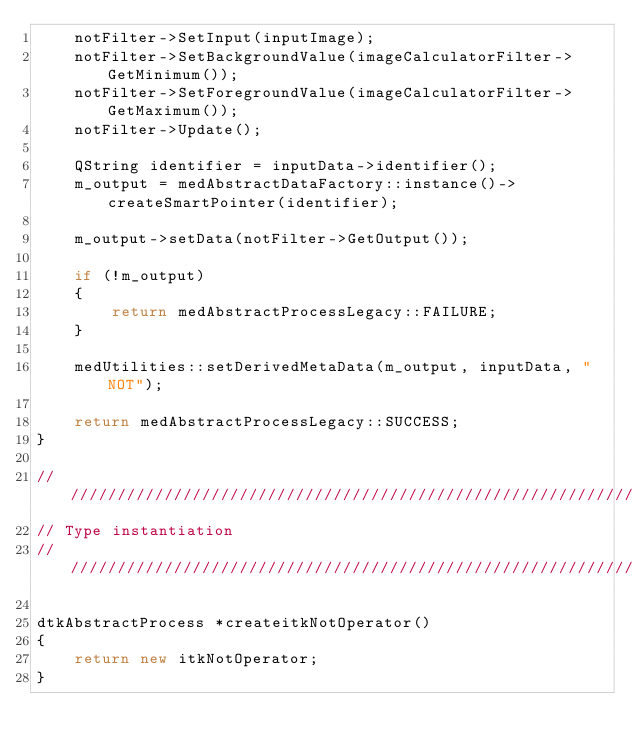Convert code to text. <code><loc_0><loc_0><loc_500><loc_500><_C++_>    notFilter->SetInput(inputImage);
    notFilter->SetBackgroundValue(imageCalculatorFilter->GetMinimum());
    notFilter->SetForegroundValue(imageCalculatorFilter->GetMaximum());
    notFilter->Update();

    QString identifier = inputData->identifier();
    m_output = medAbstractDataFactory::instance()->createSmartPointer(identifier);

    m_output->setData(notFilter->GetOutput());

    if (!m_output)
    {
        return medAbstractProcessLegacy::FAILURE;
    }

    medUtilities::setDerivedMetaData(m_output, inputData, "NOT");

    return medAbstractProcessLegacy::SUCCESS;
}        

// /////////////////////////////////////////////////////////////////
// Type instantiation
// /////////////////////////////////////////////////////////////////

dtkAbstractProcess *createitkNotOperator()
{
    return new itkNotOperator;
}
</code> 